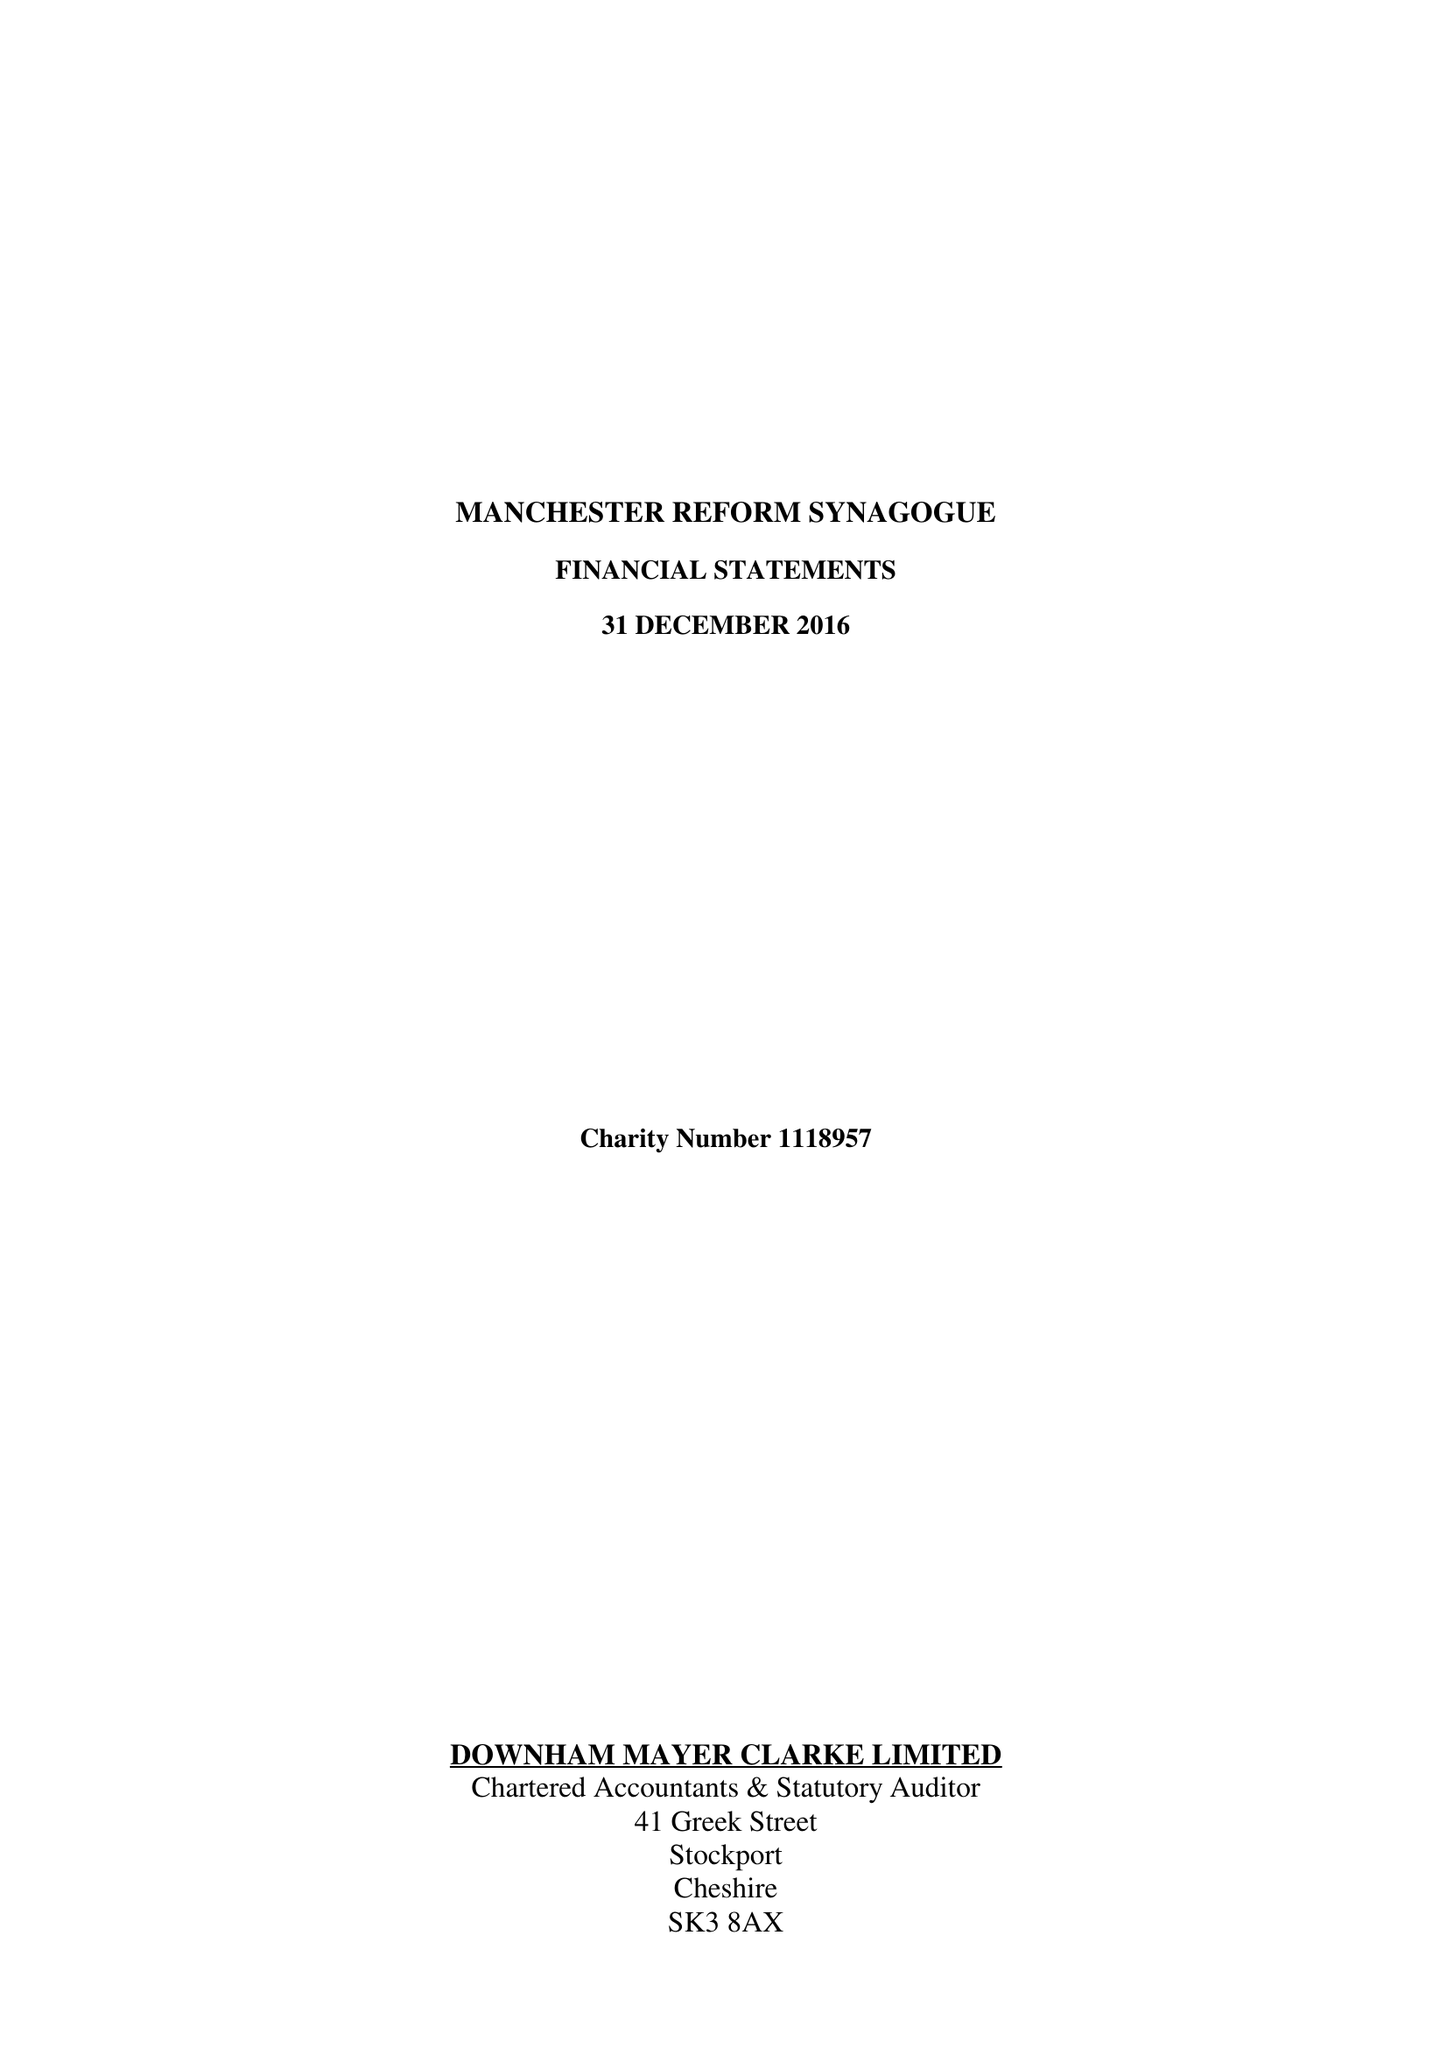What is the value for the address__post_town?
Answer the question using a single word or phrase. MANCHESTER 